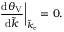Convert formula to latex. <formula><loc_0><loc_0><loc_500><loc_500>\frac { d \theta _ { V } } { d \tilde { k } } \right | _ { \tilde { k } _ { c } } = 0 .</formula> 